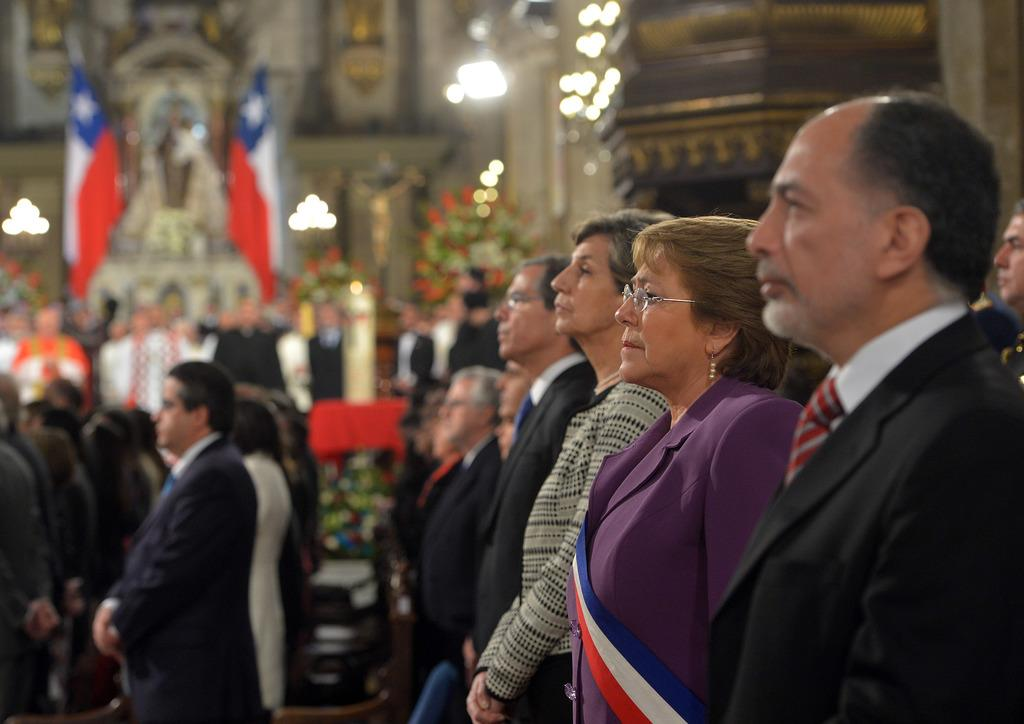How many people are in the group depicted in the image? There is a group of people in the image, but the exact number is not specified. Can you describe the attire of one person in the group? One person in the group is wearing a black blazer and a white shirt. What can be seen in the background of the image? There are flags and lights in the background of the image. What type of wood is used to make the juice in the image? There is no wood or juice present in the image. How does the person in the black blazer express regret in the image? There is no indication of regret in the image, and the person's facial expression is not described. 